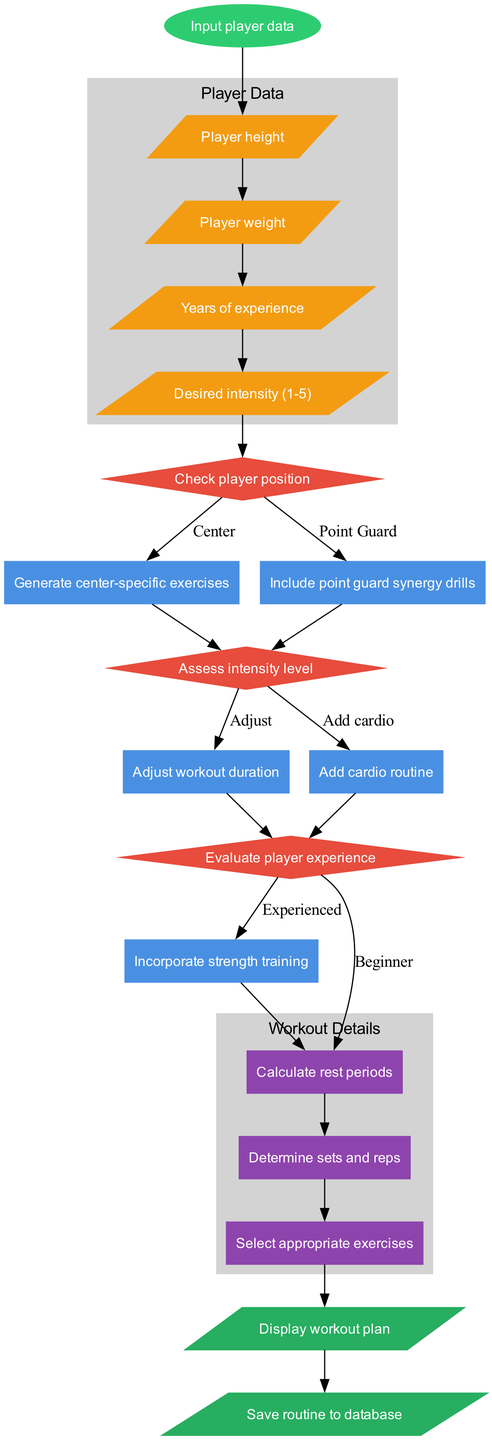What is the first step in the diagram? The first step in the diagram is labeled as "Input player data," which is represented at the start node.
Answer: Input player data How many decisions are present in the diagram? There are three decisions in the diagram, indicated by the three diamond-shaped nodes labeled "Check player position," "Assess intensity level," and "Evaluate player experience."
Answer: 3 What is generated for a center player? For a center player, the diagram indicates that "Generate center-specific exercises" will be executed as a process based on the decision regarding the player's position.
Answer: Generate center-specific exercises What happens after selecting the desired intensity level? After assessing the intensity level, the diagram indicates that the process would lead to either adjusting the workout duration or adding a cardio routine, depending on the player's experience.
Answer: Adjust workout duration or add cardio routine What is the final output of the workout routine generator? The final output of the workout routine generator consists of two outputs: "Display workout plan" and "Save routine to database," both of which occur after the subprocesses are completed.
Answer: Display workout plan and save routine to database Which subprocess calculates rest periods? The subprocess that calculates rest periods is labeled as "Calculate rest periods," which is one of the subprocesses situated in the "Workout Details" cluster.
Answer: Calculate rest periods If the player is a beginner, what subprocess follows? If the player is a beginner as per the decision regarding experience, the subprocess that follows is "Calculate rest periods," which connects to the overall workout plan creation.
Answer: Calculate rest periods What is included alongside the strength training? Alongside "Incorporate strength training," the diagram indicates that "Add cardio routine" is also included, which follows the decision based on the intensity level.
Answer: Add cardio routine 